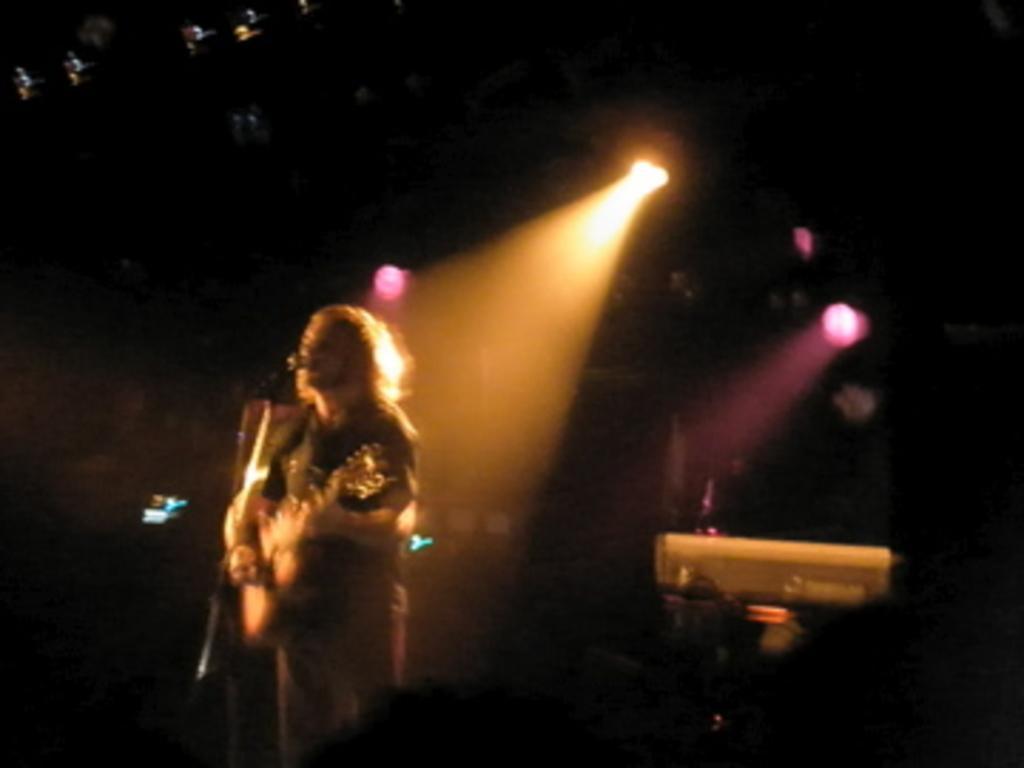In one or two sentences, can you explain what this image depicts? In this image I can see the dark picture in which I can see a person is standing and holding a musical instrument in his hand. I can see a microphone in front of him. I can see the dark background in which I can see few lights and few other objects. 